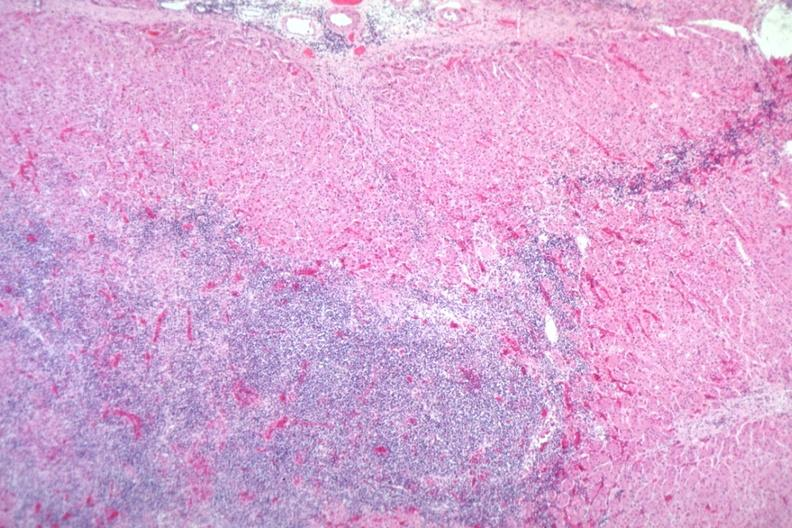where is this part in the figure?
Answer the question using a single word or phrase. Endocrine system 